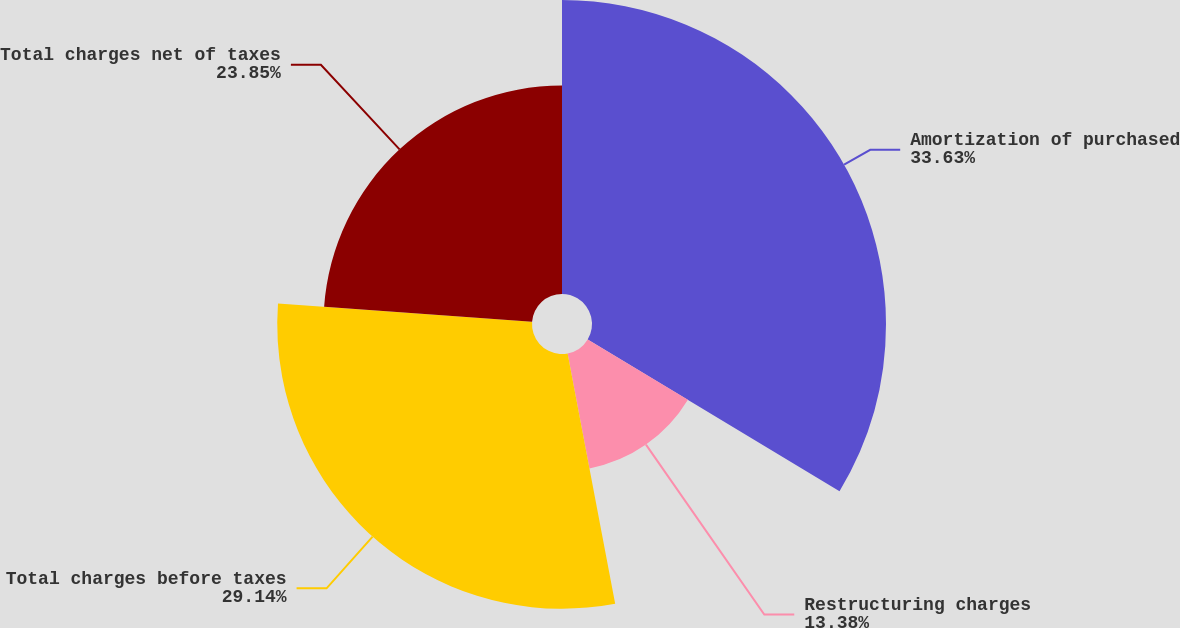<chart> <loc_0><loc_0><loc_500><loc_500><pie_chart><fcel>Amortization of purchased<fcel>Restructuring charges<fcel>Total charges before taxes<fcel>Total charges net of taxes<nl><fcel>33.63%<fcel>13.38%<fcel>29.14%<fcel>23.85%<nl></chart> 